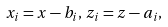Convert formula to latex. <formula><loc_0><loc_0><loc_500><loc_500>x _ { i } = x - b _ { i } , \, z _ { i } = z - a _ { i } ,</formula> 